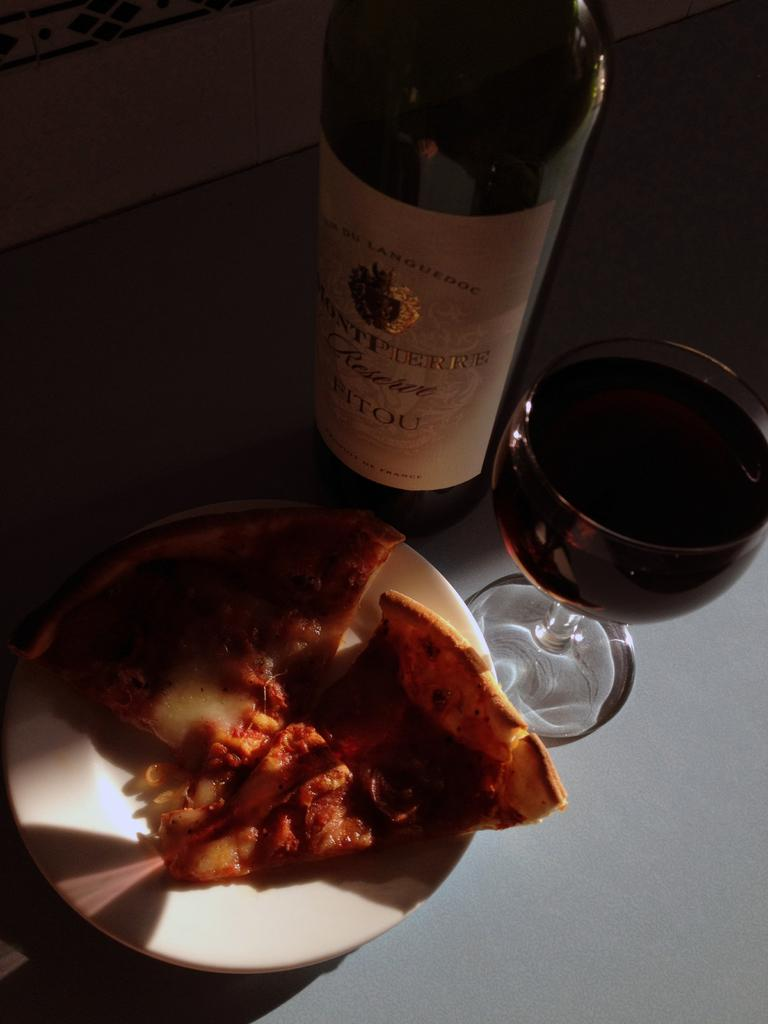<image>
Share a concise interpretation of the image provided. Bottle of alcohol which says "BITOU" on the label. 